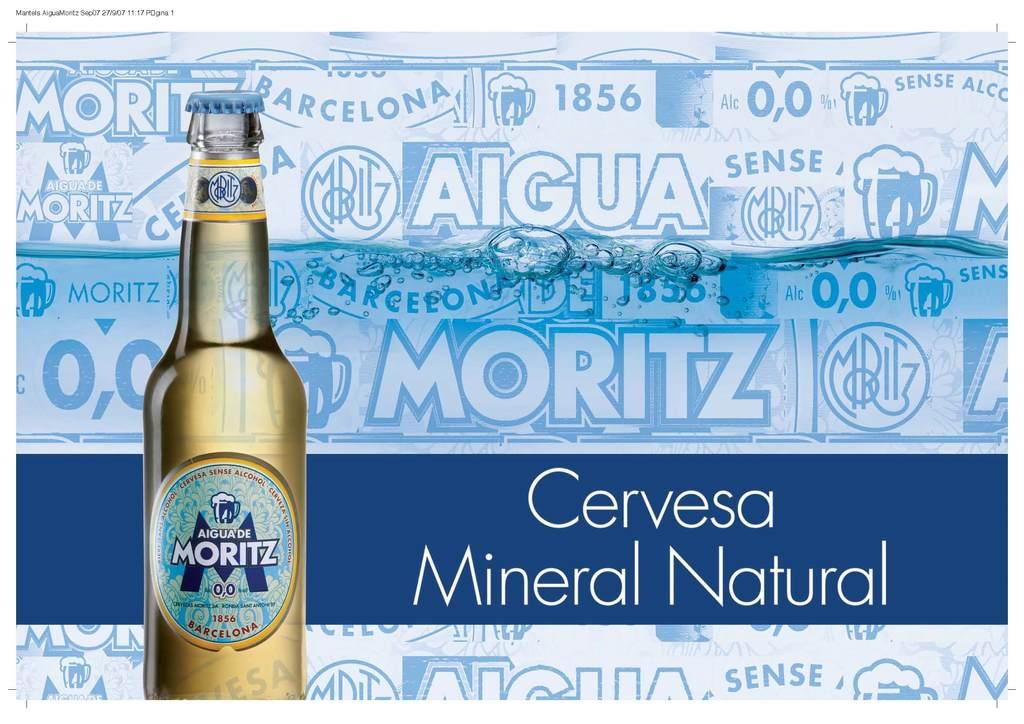<image>
Offer a succinct explanation of the picture presented. An advertisement for Moritz beer with an image of the bottle on it. 